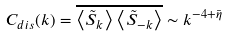Convert formula to latex. <formula><loc_0><loc_0><loc_500><loc_500>C _ { d i s } ( { k } ) = \overline { \left < \tilde { S } _ { k } \right > \left < \tilde { S } _ { - { k } } \right > } \sim k ^ { - 4 + \bar { \eta } }</formula> 